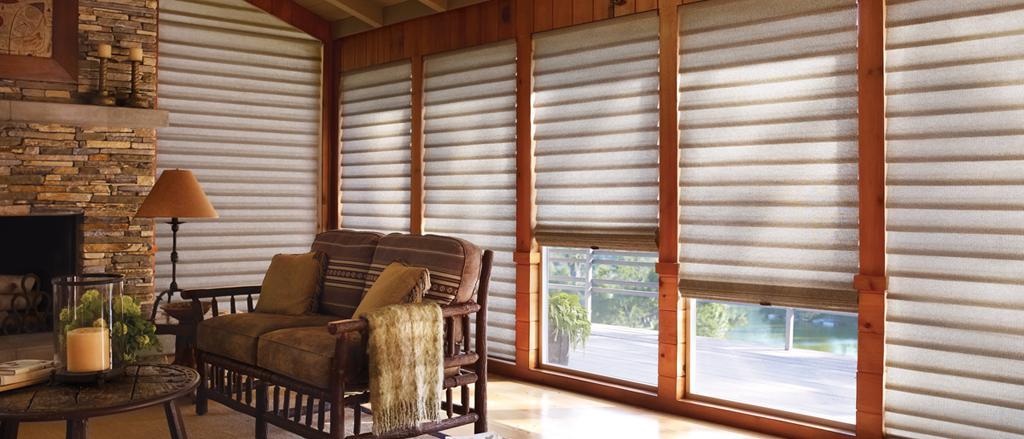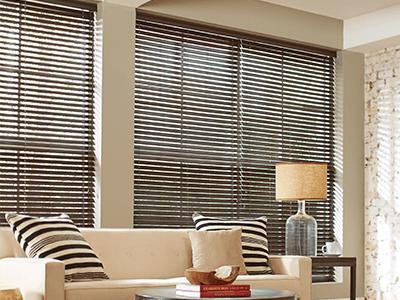The first image is the image on the left, the second image is the image on the right. Analyze the images presented: Is the assertion "The left and right image contains a total of six blinds on the windows." valid? Answer yes or no. No. The first image is the image on the left, the second image is the image on the right. Considering the images on both sides, is "At least one couch is sitting in front of the blinds." valid? Answer yes or no. Yes. 